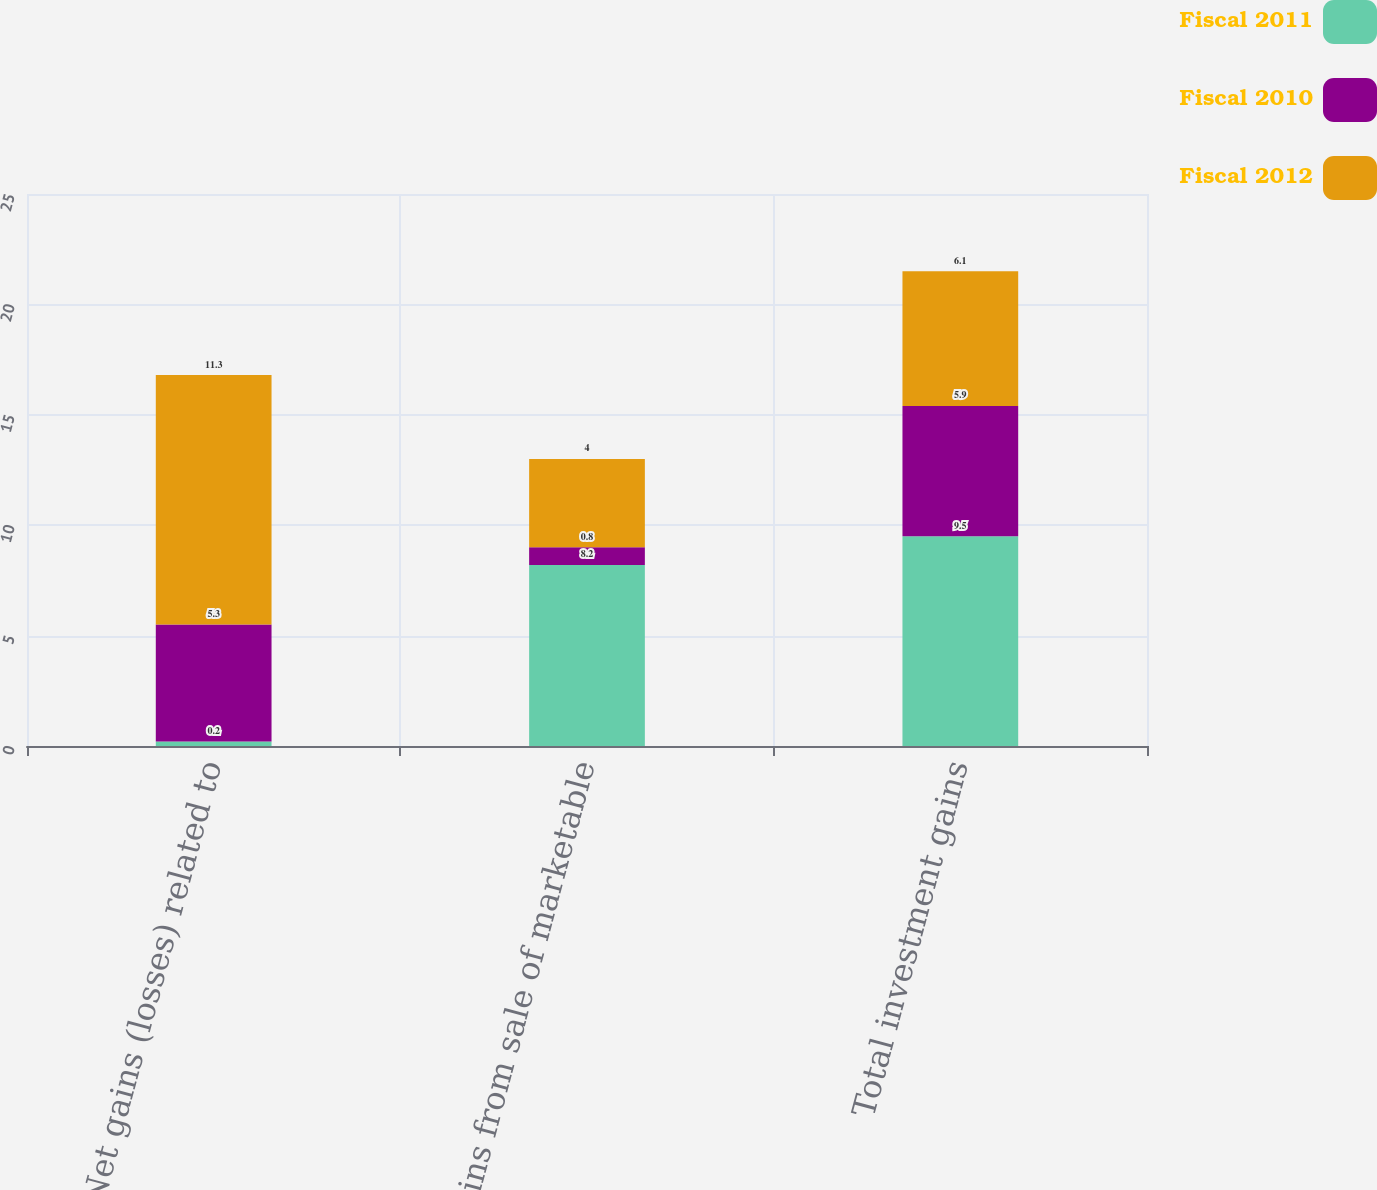Convert chart. <chart><loc_0><loc_0><loc_500><loc_500><stacked_bar_chart><ecel><fcel>Net gains (losses) related to<fcel>Gains from sale of marketable<fcel>Total investment gains<nl><fcel>Fiscal 2011<fcel>0.2<fcel>8.2<fcel>9.5<nl><fcel>Fiscal 2010<fcel>5.3<fcel>0.8<fcel>5.9<nl><fcel>Fiscal 2012<fcel>11.3<fcel>4<fcel>6.1<nl></chart> 